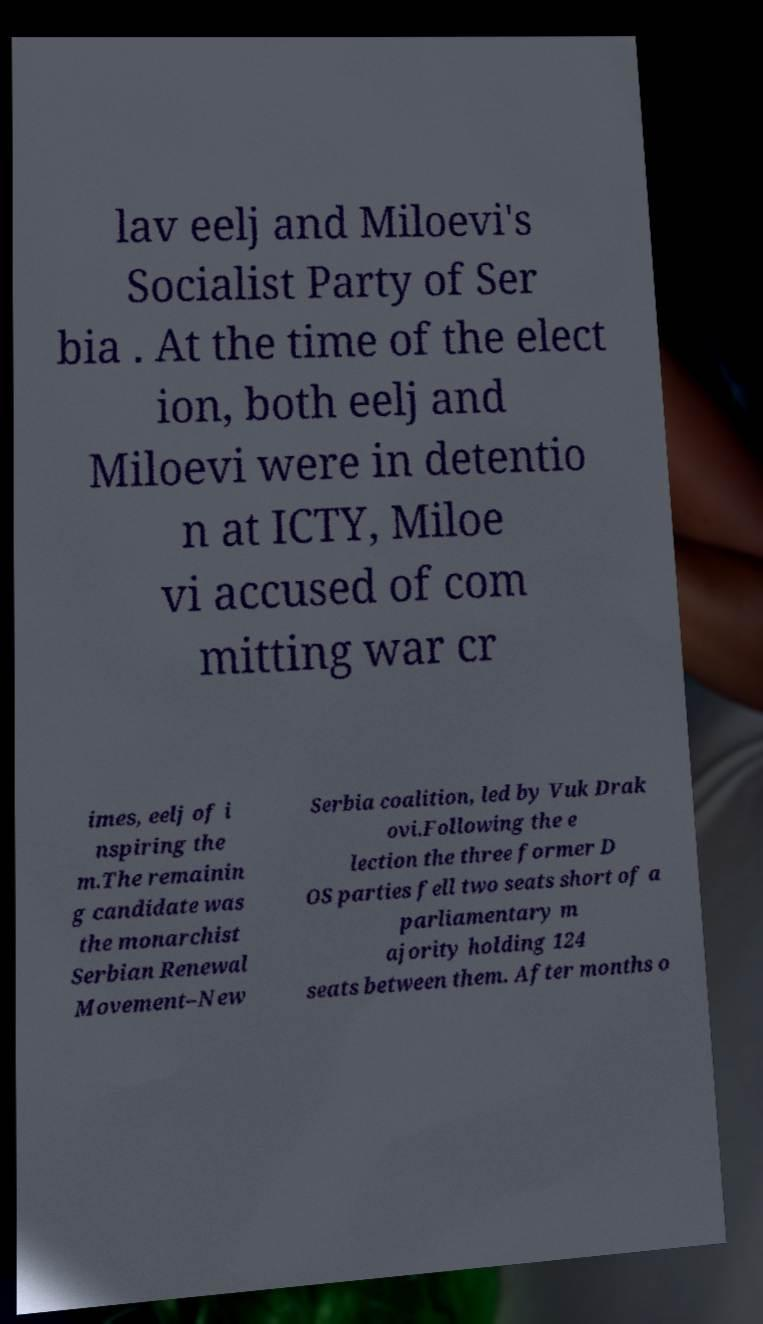There's text embedded in this image that I need extracted. Can you transcribe it verbatim? lav eelj and Miloevi's Socialist Party of Ser bia . At the time of the elect ion, both eelj and Miloevi were in detentio n at ICTY, Miloe vi accused of com mitting war cr imes, eelj of i nspiring the m.The remainin g candidate was the monarchist Serbian Renewal Movement–New Serbia coalition, led by Vuk Drak ovi.Following the e lection the three former D OS parties fell two seats short of a parliamentary m ajority holding 124 seats between them. After months o 